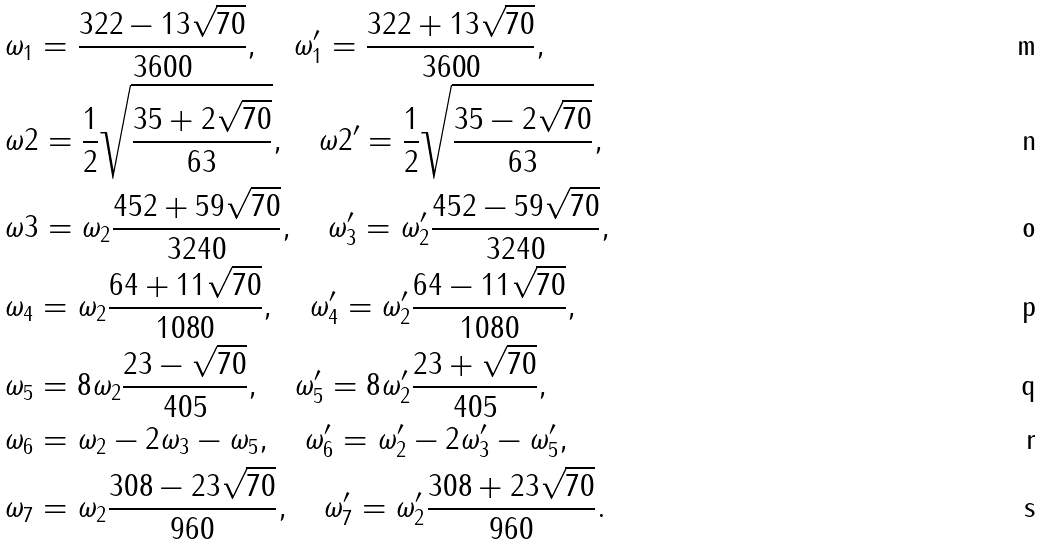<formula> <loc_0><loc_0><loc_500><loc_500>& \omega _ { 1 } = \frac { 3 2 2 - 1 3 \sqrt { 7 0 } } { 3 6 0 0 } , \quad \omega _ { 1 } ^ { \prime } = \frac { 3 2 2 + 1 3 \sqrt { 7 0 } } { 3 6 0 0 } , \\ & \omega { 2 } = \frac { 1 } { 2 } \sqrt { \frac { 3 5 + 2 \sqrt { 7 0 } } { 6 3 } } , \quad \omega { 2 } ^ { \prime } = \frac { 1 } { 2 } \sqrt { \frac { 3 5 - 2 \sqrt { 7 0 } } { 6 3 } } , \\ & \omega { 3 } = \omega _ { 2 } \frac { 4 5 2 + 5 9 \sqrt { 7 0 } } { 3 2 4 0 } , \quad \omega ^ { \prime } _ { 3 } = \omega ^ { \prime } _ { 2 } \frac { 4 5 2 - 5 9 \sqrt { 7 0 } } { 3 2 4 0 } , \\ & \omega _ { 4 } = \omega _ { 2 } \frac { 6 4 + 1 1 \sqrt { 7 0 } } { 1 0 8 0 } , \quad \omega ^ { \prime } _ { 4 } = \omega ^ { \prime } _ { 2 } \frac { 6 4 - 1 1 \sqrt { 7 0 } } { 1 0 8 0 } , \\ & \omega _ { 5 } = 8 \omega _ { 2 } \frac { 2 3 - \sqrt { 7 0 } } { 4 0 5 } , \quad \omega ^ { \prime } _ { 5 } = 8 \omega ^ { \prime } _ { 2 } \frac { 2 3 + \sqrt { 7 0 } } { 4 0 5 } , \\ & \omega _ { 6 } = \omega _ { 2 } - 2 \omega _ { 3 } - \omega _ { 5 } , \quad \omega ^ { \prime } _ { 6 } = \omega ^ { \prime } _ { 2 } - 2 \omega ^ { \prime } _ { 3 } - \omega ^ { \prime } _ { 5 } , \\ & \omega _ { 7 } = \omega _ { 2 } \frac { 3 0 8 - 2 3 \sqrt { 7 0 } } { 9 6 0 } , \quad \omega ^ { \prime } _ { 7 } = \omega ^ { \prime } _ { 2 } \frac { 3 0 8 + 2 3 \sqrt { 7 0 } } { 9 6 0 } .</formula> 